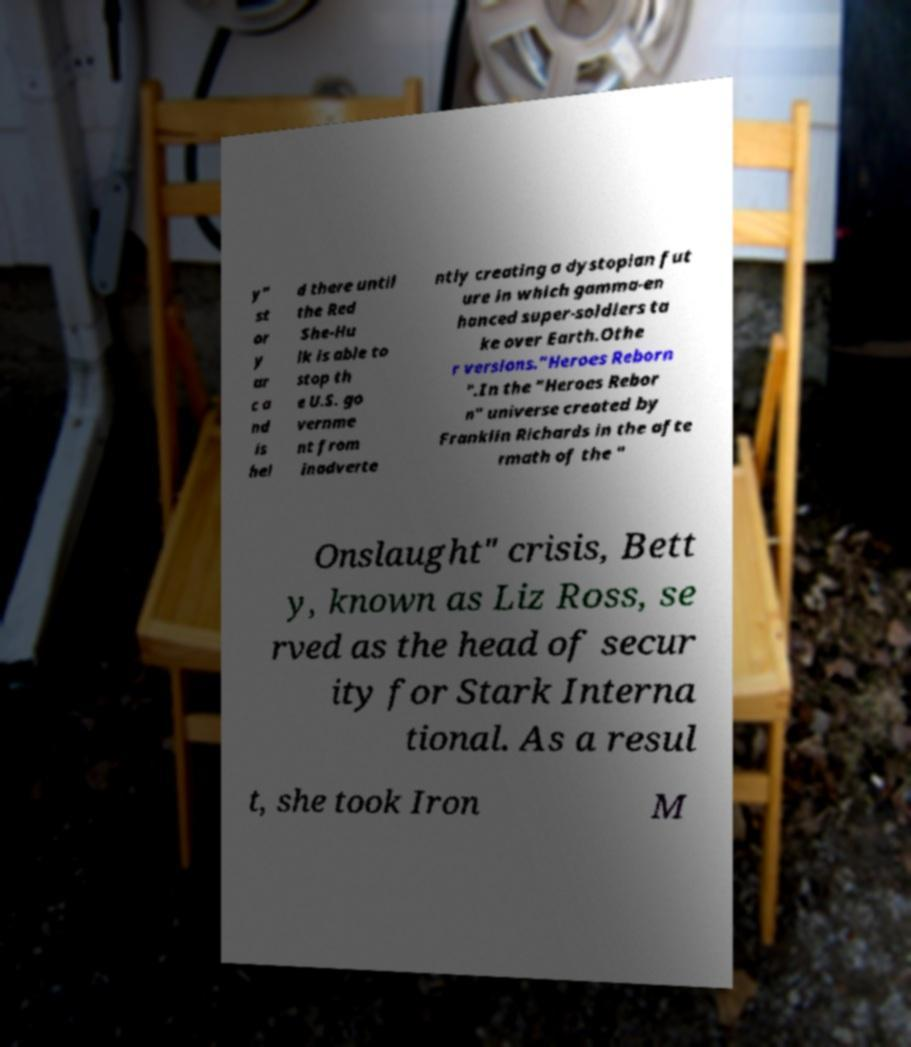For documentation purposes, I need the text within this image transcribed. Could you provide that? y" st or y ar c a nd is hel d there until the Red She-Hu lk is able to stop th e U.S. go vernme nt from inadverte ntly creating a dystopian fut ure in which gamma-en hanced super-soldiers ta ke over Earth.Othe r versions."Heroes Reborn ".In the "Heroes Rebor n" universe created by Franklin Richards in the afte rmath of the " Onslaught" crisis, Bett y, known as Liz Ross, se rved as the head of secur ity for Stark Interna tional. As a resul t, she took Iron M 